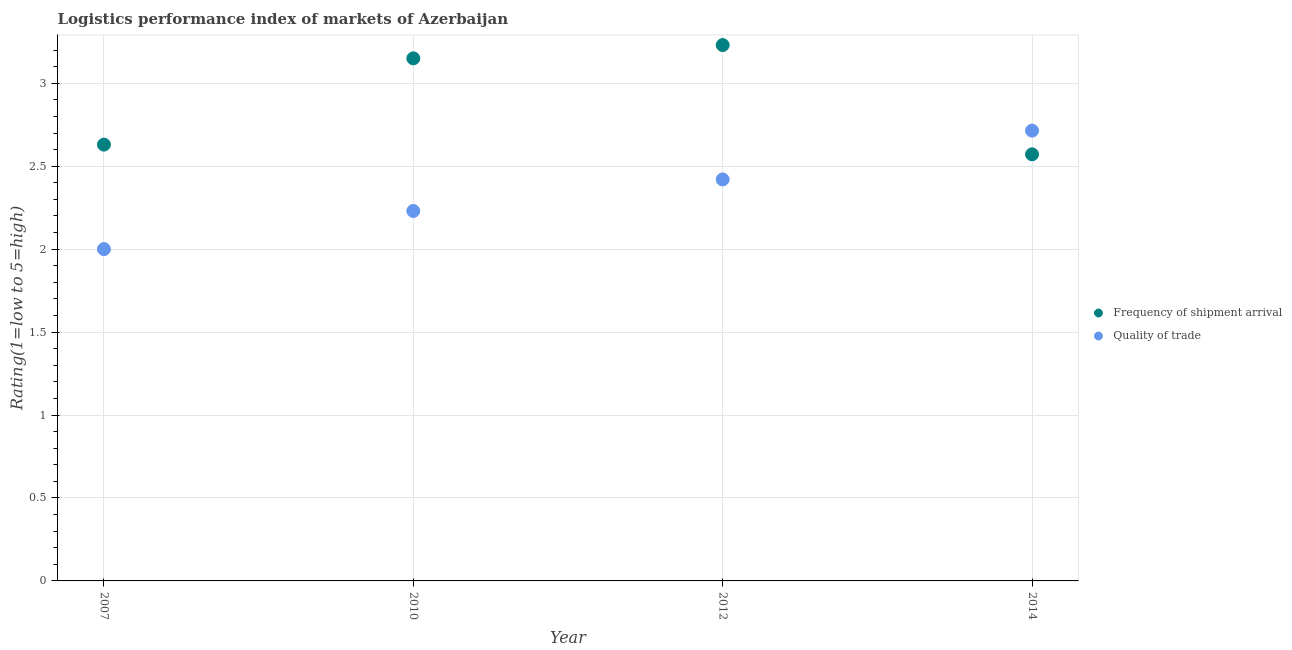How many different coloured dotlines are there?
Provide a succinct answer. 2. Is the number of dotlines equal to the number of legend labels?
Provide a short and direct response. Yes. What is the lpi of frequency of shipment arrival in 2012?
Your answer should be compact. 3.23. Across all years, what is the maximum lpi of frequency of shipment arrival?
Provide a succinct answer. 3.23. Across all years, what is the minimum lpi of frequency of shipment arrival?
Offer a terse response. 2.57. In which year was the lpi of frequency of shipment arrival maximum?
Provide a succinct answer. 2012. In which year was the lpi quality of trade minimum?
Your response must be concise. 2007. What is the total lpi quality of trade in the graph?
Make the answer very short. 9.36. What is the difference between the lpi quality of trade in 2007 and that in 2014?
Provide a short and direct response. -0.71. What is the difference between the lpi of frequency of shipment arrival in 2014 and the lpi quality of trade in 2012?
Give a very brief answer. 0.15. What is the average lpi quality of trade per year?
Provide a short and direct response. 2.34. In the year 2012, what is the difference between the lpi quality of trade and lpi of frequency of shipment arrival?
Your answer should be compact. -0.81. In how many years, is the lpi quality of trade greater than 1?
Offer a very short reply. 4. What is the ratio of the lpi quality of trade in 2007 to that in 2014?
Keep it short and to the point. 0.74. Is the lpi quality of trade in 2007 less than that in 2010?
Make the answer very short. Yes. What is the difference between the highest and the second highest lpi quality of trade?
Offer a terse response. 0.29. What is the difference between the highest and the lowest lpi of frequency of shipment arrival?
Provide a succinct answer. 0.66. In how many years, is the lpi quality of trade greater than the average lpi quality of trade taken over all years?
Your response must be concise. 2. Is the sum of the lpi quality of trade in 2007 and 2012 greater than the maximum lpi of frequency of shipment arrival across all years?
Offer a terse response. Yes. How many dotlines are there?
Provide a succinct answer. 2. What is the difference between two consecutive major ticks on the Y-axis?
Give a very brief answer. 0.5. Does the graph contain any zero values?
Make the answer very short. No. Does the graph contain grids?
Your response must be concise. Yes. How many legend labels are there?
Offer a very short reply. 2. How are the legend labels stacked?
Provide a succinct answer. Vertical. What is the title of the graph?
Make the answer very short. Logistics performance index of markets of Azerbaijan. Does "Boys" appear as one of the legend labels in the graph?
Your answer should be compact. No. What is the label or title of the X-axis?
Keep it short and to the point. Year. What is the label or title of the Y-axis?
Keep it short and to the point. Rating(1=low to 5=high). What is the Rating(1=low to 5=high) of Frequency of shipment arrival in 2007?
Your answer should be compact. 2.63. What is the Rating(1=low to 5=high) of Frequency of shipment arrival in 2010?
Keep it short and to the point. 3.15. What is the Rating(1=low to 5=high) in Quality of trade in 2010?
Provide a succinct answer. 2.23. What is the Rating(1=low to 5=high) of Frequency of shipment arrival in 2012?
Your answer should be compact. 3.23. What is the Rating(1=low to 5=high) in Quality of trade in 2012?
Your answer should be compact. 2.42. What is the Rating(1=low to 5=high) in Frequency of shipment arrival in 2014?
Your answer should be compact. 2.57. What is the Rating(1=low to 5=high) in Quality of trade in 2014?
Offer a very short reply. 2.71. Across all years, what is the maximum Rating(1=low to 5=high) of Frequency of shipment arrival?
Make the answer very short. 3.23. Across all years, what is the maximum Rating(1=low to 5=high) of Quality of trade?
Your response must be concise. 2.71. Across all years, what is the minimum Rating(1=low to 5=high) of Frequency of shipment arrival?
Your response must be concise. 2.57. Across all years, what is the minimum Rating(1=low to 5=high) of Quality of trade?
Your answer should be compact. 2. What is the total Rating(1=low to 5=high) in Frequency of shipment arrival in the graph?
Give a very brief answer. 11.58. What is the total Rating(1=low to 5=high) in Quality of trade in the graph?
Give a very brief answer. 9.36. What is the difference between the Rating(1=low to 5=high) of Frequency of shipment arrival in 2007 and that in 2010?
Offer a terse response. -0.52. What is the difference between the Rating(1=low to 5=high) in Quality of trade in 2007 and that in 2010?
Your answer should be compact. -0.23. What is the difference between the Rating(1=low to 5=high) of Frequency of shipment arrival in 2007 and that in 2012?
Offer a very short reply. -0.6. What is the difference between the Rating(1=low to 5=high) in Quality of trade in 2007 and that in 2012?
Your answer should be compact. -0.42. What is the difference between the Rating(1=low to 5=high) in Frequency of shipment arrival in 2007 and that in 2014?
Your answer should be compact. 0.06. What is the difference between the Rating(1=low to 5=high) in Quality of trade in 2007 and that in 2014?
Offer a very short reply. -0.71. What is the difference between the Rating(1=low to 5=high) in Frequency of shipment arrival in 2010 and that in 2012?
Your response must be concise. -0.08. What is the difference between the Rating(1=low to 5=high) in Quality of trade in 2010 and that in 2012?
Ensure brevity in your answer.  -0.19. What is the difference between the Rating(1=low to 5=high) in Frequency of shipment arrival in 2010 and that in 2014?
Offer a very short reply. 0.58. What is the difference between the Rating(1=low to 5=high) in Quality of trade in 2010 and that in 2014?
Your response must be concise. -0.48. What is the difference between the Rating(1=low to 5=high) in Frequency of shipment arrival in 2012 and that in 2014?
Your answer should be very brief. 0.66. What is the difference between the Rating(1=low to 5=high) in Quality of trade in 2012 and that in 2014?
Offer a very short reply. -0.29. What is the difference between the Rating(1=low to 5=high) in Frequency of shipment arrival in 2007 and the Rating(1=low to 5=high) in Quality of trade in 2010?
Your answer should be very brief. 0.4. What is the difference between the Rating(1=low to 5=high) of Frequency of shipment arrival in 2007 and the Rating(1=low to 5=high) of Quality of trade in 2012?
Make the answer very short. 0.21. What is the difference between the Rating(1=low to 5=high) in Frequency of shipment arrival in 2007 and the Rating(1=low to 5=high) in Quality of trade in 2014?
Offer a terse response. -0.08. What is the difference between the Rating(1=low to 5=high) of Frequency of shipment arrival in 2010 and the Rating(1=low to 5=high) of Quality of trade in 2012?
Offer a very short reply. 0.73. What is the difference between the Rating(1=low to 5=high) in Frequency of shipment arrival in 2010 and the Rating(1=low to 5=high) in Quality of trade in 2014?
Your answer should be compact. 0.44. What is the difference between the Rating(1=low to 5=high) of Frequency of shipment arrival in 2012 and the Rating(1=low to 5=high) of Quality of trade in 2014?
Your response must be concise. 0.52. What is the average Rating(1=low to 5=high) in Frequency of shipment arrival per year?
Your answer should be compact. 2.9. What is the average Rating(1=low to 5=high) in Quality of trade per year?
Keep it short and to the point. 2.34. In the year 2007, what is the difference between the Rating(1=low to 5=high) of Frequency of shipment arrival and Rating(1=low to 5=high) of Quality of trade?
Your answer should be very brief. 0.63. In the year 2012, what is the difference between the Rating(1=low to 5=high) of Frequency of shipment arrival and Rating(1=low to 5=high) of Quality of trade?
Provide a short and direct response. 0.81. In the year 2014, what is the difference between the Rating(1=low to 5=high) in Frequency of shipment arrival and Rating(1=low to 5=high) in Quality of trade?
Provide a succinct answer. -0.14. What is the ratio of the Rating(1=low to 5=high) in Frequency of shipment arrival in 2007 to that in 2010?
Your answer should be compact. 0.83. What is the ratio of the Rating(1=low to 5=high) in Quality of trade in 2007 to that in 2010?
Make the answer very short. 0.9. What is the ratio of the Rating(1=low to 5=high) of Frequency of shipment arrival in 2007 to that in 2012?
Your response must be concise. 0.81. What is the ratio of the Rating(1=low to 5=high) in Quality of trade in 2007 to that in 2012?
Your answer should be very brief. 0.83. What is the ratio of the Rating(1=low to 5=high) in Frequency of shipment arrival in 2007 to that in 2014?
Keep it short and to the point. 1.02. What is the ratio of the Rating(1=low to 5=high) of Quality of trade in 2007 to that in 2014?
Offer a very short reply. 0.74. What is the ratio of the Rating(1=low to 5=high) in Frequency of shipment arrival in 2010 to that in 2012?
Offer a very short reply. 0.98. What is the ratio of the Rating(1=low to 5=high) of Quality of trade in 2010 to that in 2012?
Offer a terse response. 0.92. What is the ratio of the Rating(1=low to 5=high) in Frequency of shipment arrival in 2010 to that in 2014?
Offer a terse response. 1.23. What is the ratio of the Rating(1=low to 5=high) of Quality of trade in 2010 to that in 2014?
Provide a short and direct response. 0.82. What is the ratio of the Rating(1=low to 5=high) in Frequency of shipment arrival in 2012 to that in 2014?
Your answer should be compact. 1.26. What is the ratio of the Rating(1=low to 5=high) in Quality of trade in 2012 to that in 2014?
Your answer should be very brief. 0.89. What is the difference between the highest and the second highest Rating(1=low to 5=high) of Frequency of shipment arrival?
Provide a short and direct response. 0.08. What is the difference between the highest and the second highest Rating(1=low to 5=high) of Quality of trade?
Offer a very short reply. 0.29. What is the difference between the highest and the lowest Rating(1=low to 5=high) of Frequency of shipment arrival?
Offer a very short reply. 0.66. 